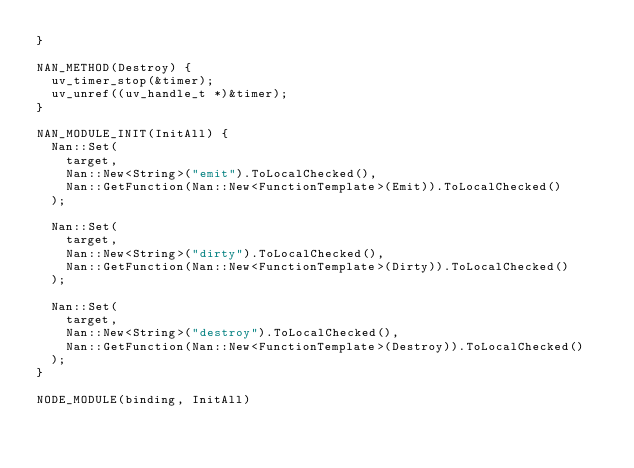Convert code to text. <code><loc_0><loc_0><loc_500><loc_500><_C++_>}

NAN_METHOD(Destroy) {
  uv_timer_stop(&timer);
  uv_unref((uv_handle_t *)&timer);
}

NAN_MODULE_INIT(InitAll) {
  Nan::Set(
    target,
    Nan::New<String>("emit").ToLocalChecked(),
    Nan::GetFunction(Nan::New<FunctionTemplate>(Emit)).ToLocalChecked()
  );

  Nan::Set(
    target,
    Nan::New<String>("dirty").ToLocalChecked(),
    Nan::GetFunction(Nan::New<FunctionTemplate>(Dirty)).ToLocalChecked()
  );

  Nan::Set(
    target,
    Nan::New<String>("destroy").ToLocalChecked(),
    Nan::GetFunction(Nan::New<FunctionTemplate>(Destroy)).ToLocalChecked()
  );
}

NODE_MODULE(binding, InitAll)
</code> 